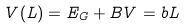<formula> <loc_0><loc_0><loc_500><loc_500>V ( L ) = E _ { G } + B V = b L</formula> 